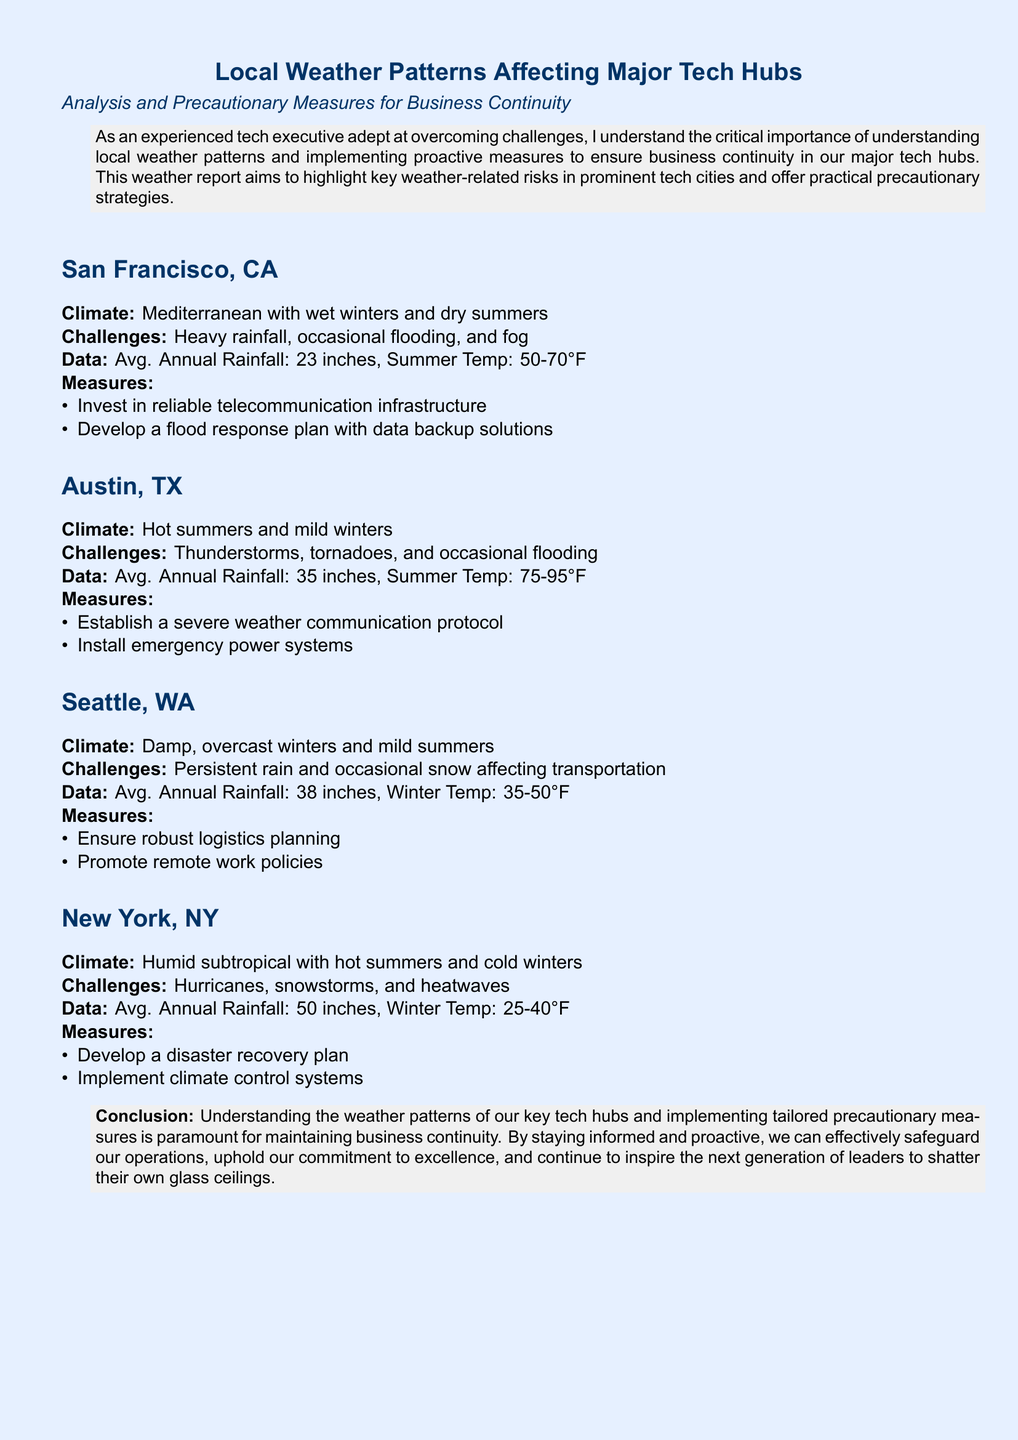What is the average annual rainfall in San Francisco? The document states that San Francisco has an average annual rainfall of 23 inches.
Answer: 23 inches What climate type is associated with Austin, TX? The document categorizes Austin's climate as hot summers and mild winters.
Answer: Hot summers and mild winters What precautionary measure is suggested for Seattle? The report recommends ensuring robust logistics planning as a precautionary measure for Seattle.
Answer: Ensure robust logistics planning How many inches of rainfall does New York receive annually? According to the document, New York has an average annual rainfall of 50 inches.
Answer: 50 inches What specific weather challenge does Austin face? The document lists thunderstorms, tornadoes, and occasional flooding as challenges for Austin.
Answer: Thunderstorms, tornadoes, and occasional flooding What is the summer temperature range for San Francisco? The summer temperature range for San Francisco is specified in the document as 50-70°F.
Answer: 50-70°F Which tech hub faces hurricanes? The document mentions hurricanes as a challenge specific to New York.
Answer: New York What is one measure to be taken in case of flooding in San Francisco? The document advises developing a flood response plan with data backup solutions for flooding in San Francisco.
Answer: Develop a flood response plan with data backup solutions 